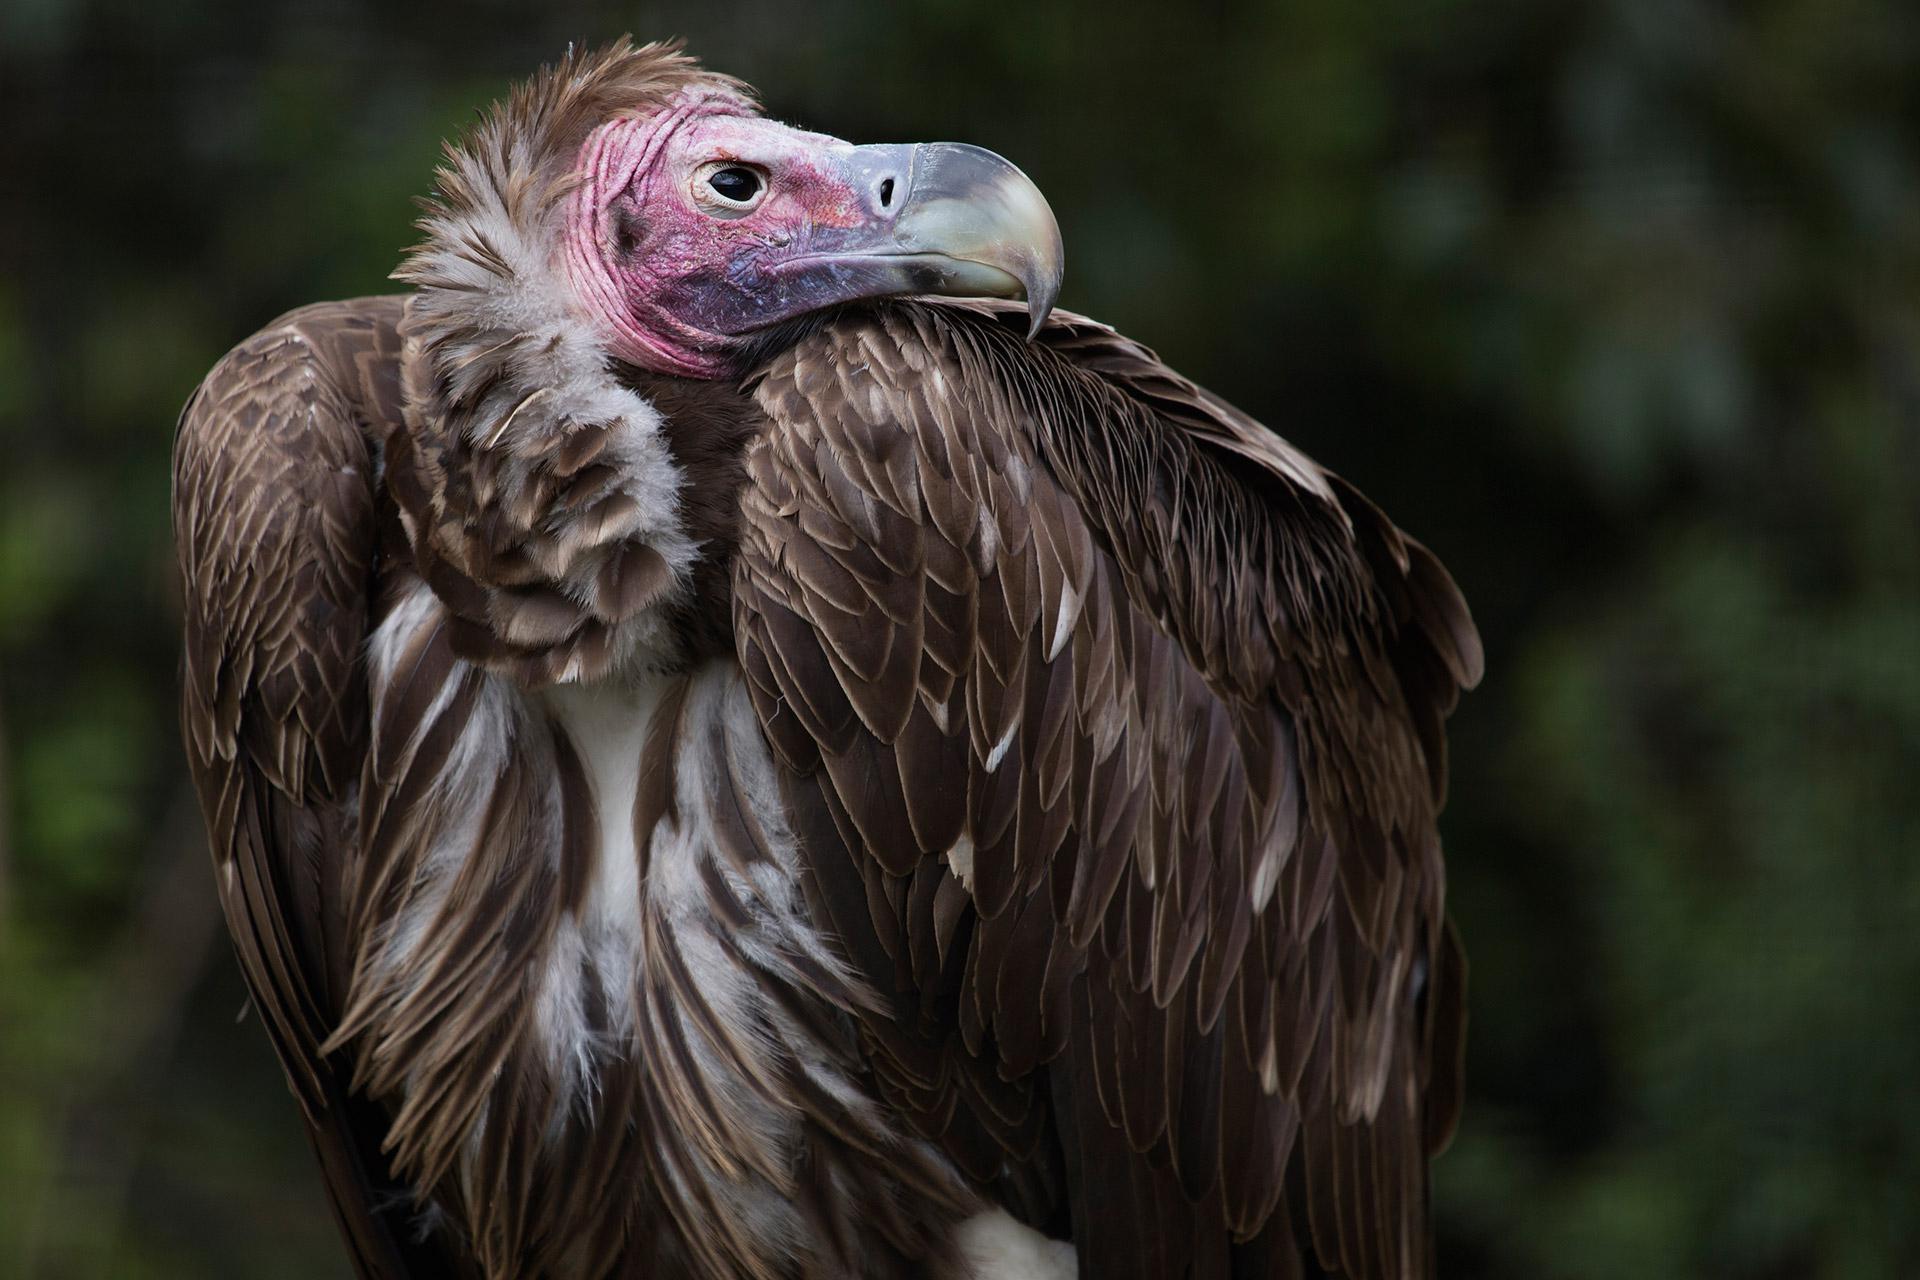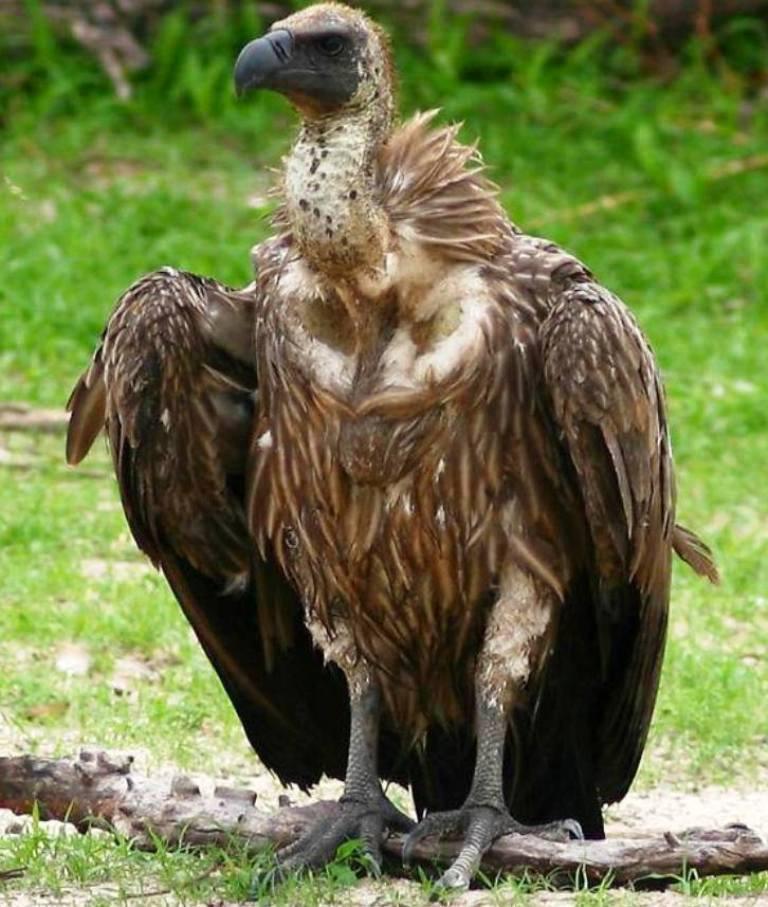The first image is the image on the left, the second image is the image on the right. Given the left and right images, does the statement "One image shows a white-headed vulture in flight with its wings spread." hold true? Answer yes or no. No. The first image is the image on the left, the second image is the image on the right. Evaluate the accuracy of this statement regarding the images: "The left and right image contains the same vultures.". Is it true? Answer yes or no. Yes. 